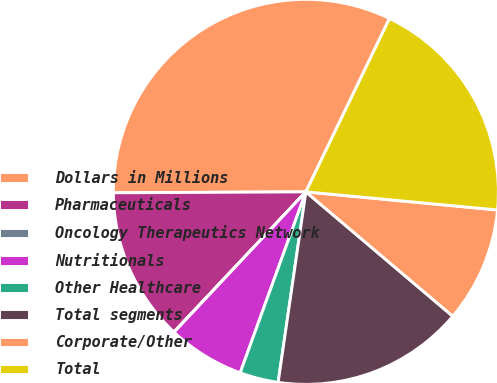Convert chart. <chart><loc_0><loc_0><loc_500><loc_500><pie_chart><fcel>Dollars in Millions<fcel>Pharmaceuticals<fcel>Oncology Therapeutics Network<fcel>Nutritionals<fcel>Other Healthcare<fcel>Total segments<fcel>Corporate/Other<fcel>Total<nl><fcel>32.23%<fcel>12.9%<fcel>0.02%<fcel>6.46%<fcel>3.24%<fcel>16.12%<fcel>9.68%<fcel>19.35%<nl></chart> 